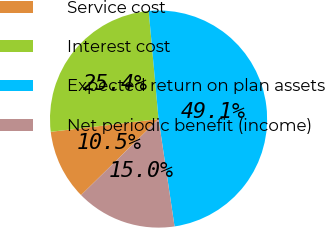<chart> <loc_0><loc_0><loc_500><loc_500><pie_chart><fcel>Service cost<fcel>Interest cost<fcel>Expected return on plan assets<fcel>Net periodic benefit (income)<nl><fcel>10.48%<fcel>25.43%<fcel>49.1%<fcel>15.0%<nl></chart> 